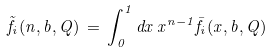Convert formula to latex. <formula><loc_0><loc_0><loc_500><loc_500>\tilde { f } _ { i } ( n , b , Q ) \, = \, \int _ { 0 } ^ { 1 } d x \, x ^ { n - 1 } \bar { f } _ { i } ( x , b , Q )</formula> 